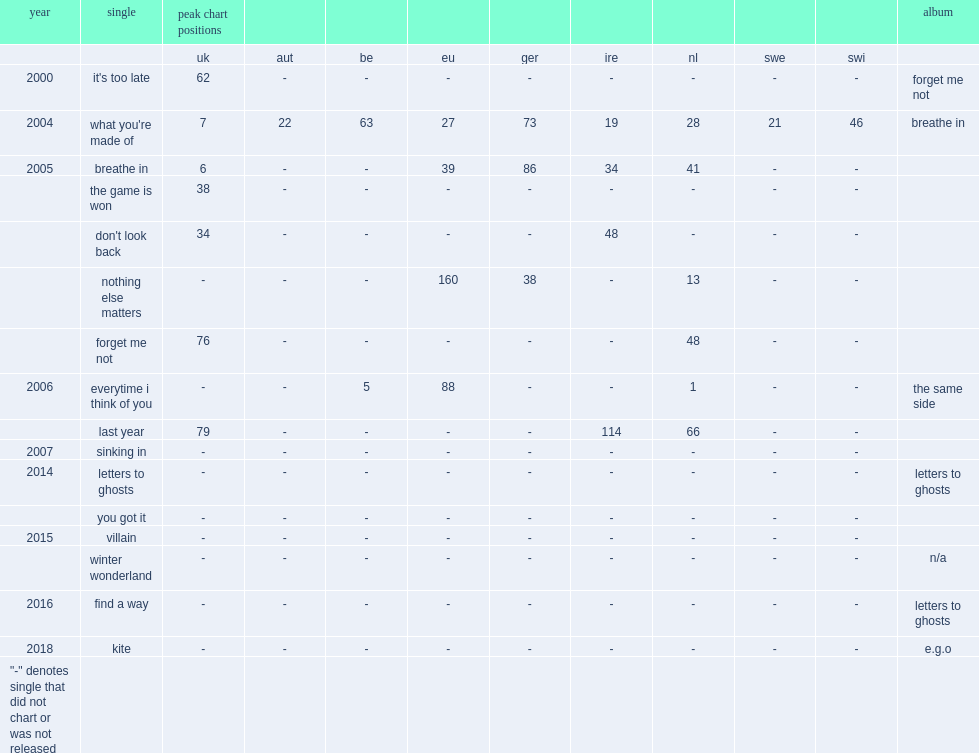What is the peak chart position on uk charts for lucie silvas single "it's too late" from the album "forget me not"? 62.0. 